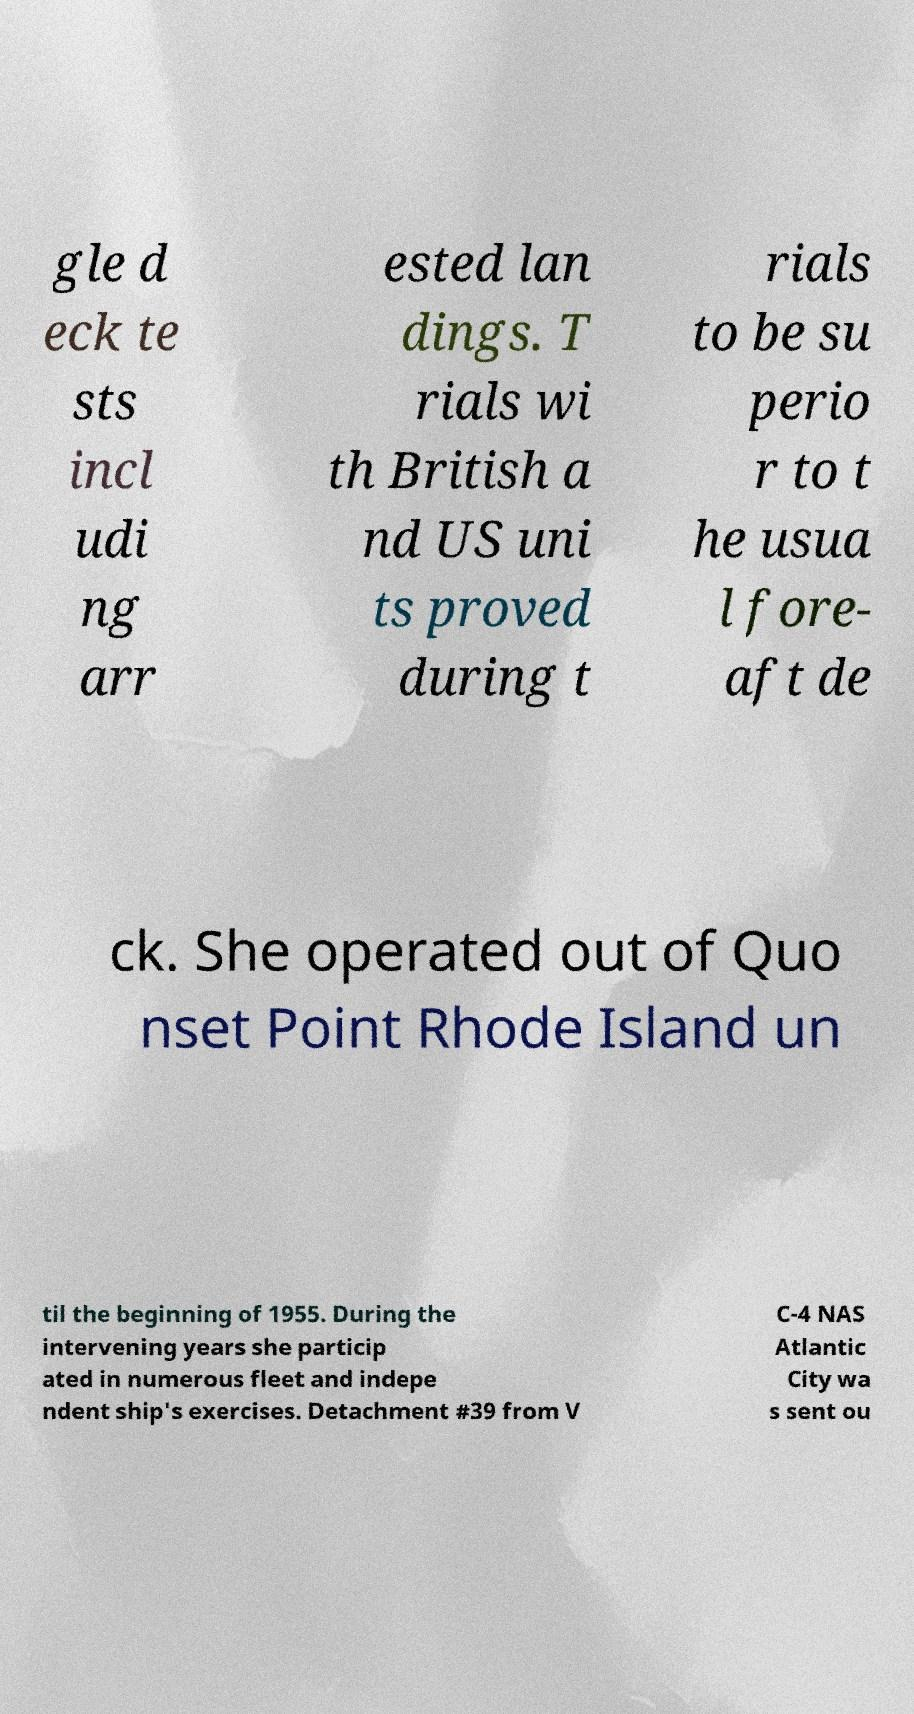For documentation purposes, I need the text within this image transcribed. Could you provide that? gle d eck te sts incl udi ng arr ested lan dings. T rials wi th British a nd US uni ts proved during t rials to be su perio r to t he usua l fore- aft de ck. She operated out of Quo nset Point Rhode Island un til the beginning of 1955. During the intervening years she particip ated in numerous fleet and indepe ndent ship's exercises. Detachment #39 from V C-4 NAS Atlantic City wa s sent ou 